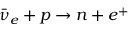<formula> <loc_0><loc_0><loc_500><loc_500>{ \bar { \nu } } _ { e } + p \to n + e ^ { + }</formula> 